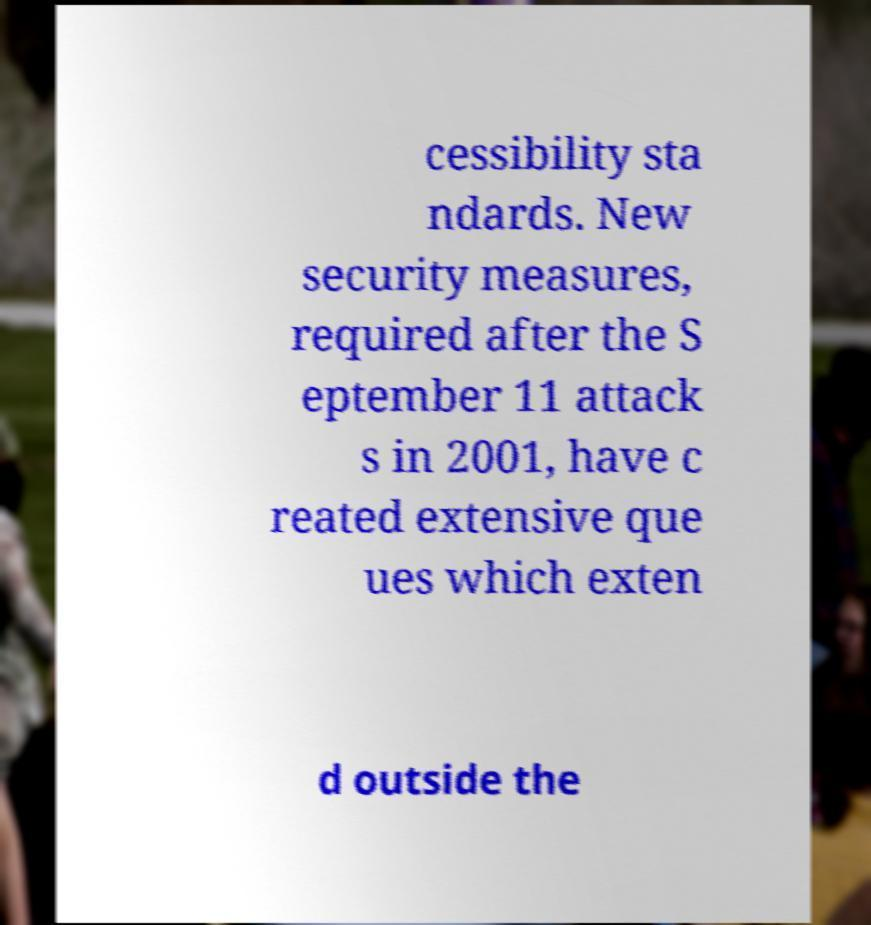Can you read and provide the text displayed in the image?This photo seems to have some interesting text. Can you extract and type it out for me? cessibility sta ndards. New security measures, required after the S eptember 11 attack s in 2001, have c reated extensive que ues which exten d outside the 